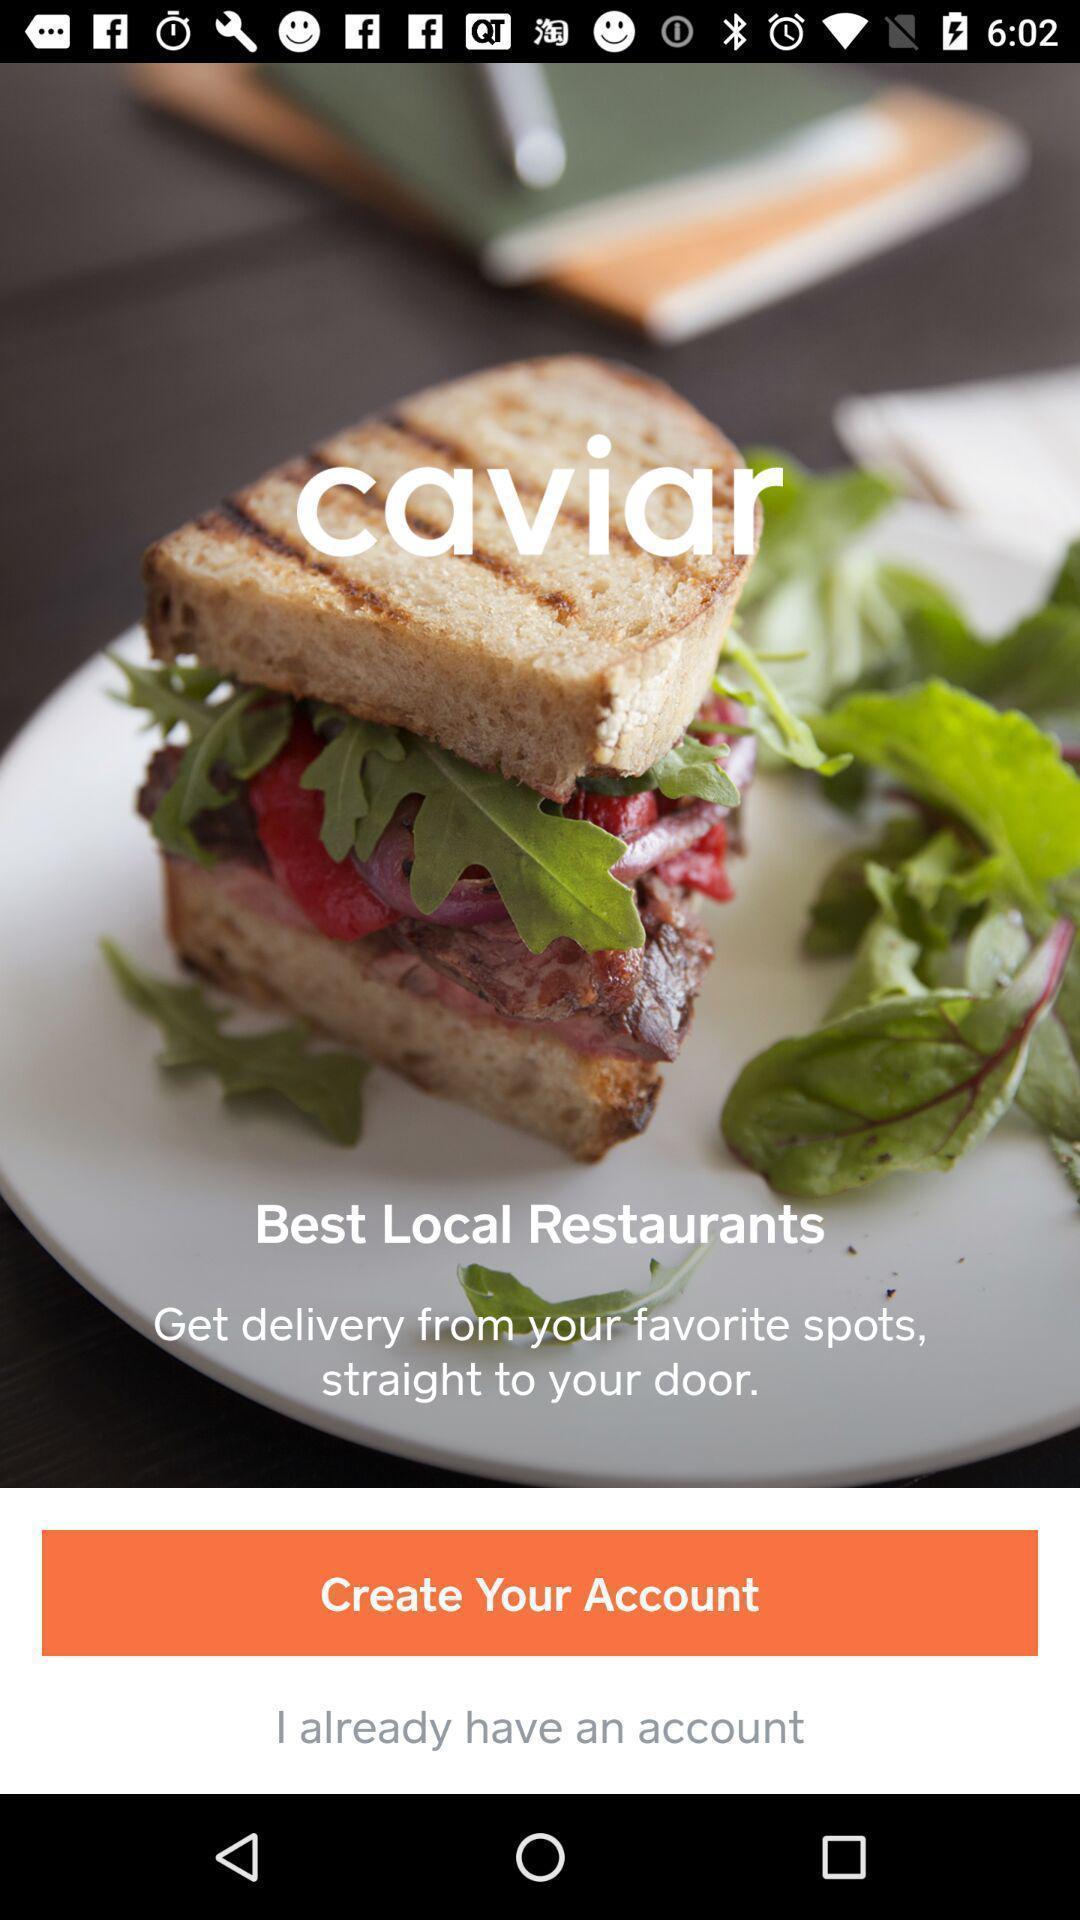Give me a narrative description of this picture. Welcome page of a food delivery app. 